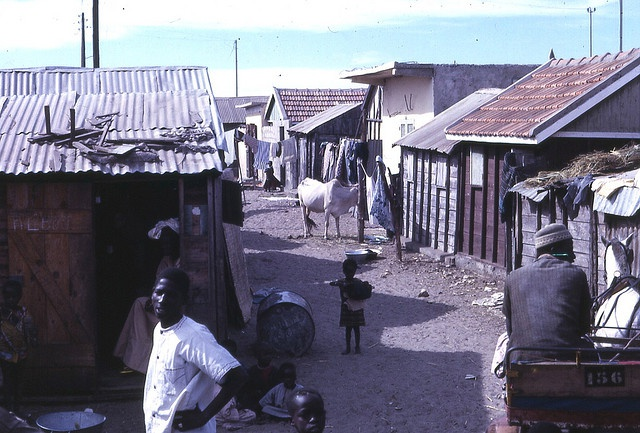Describe the objects in this image and their specific colors. I can see people in white, black, lavender, darkgray, and gray tones, people in white, black, purple, and gray tones, people in white, black, and purple tones, horse in white, gray, and black tones, and people in white, black, and purple tones in this image. 